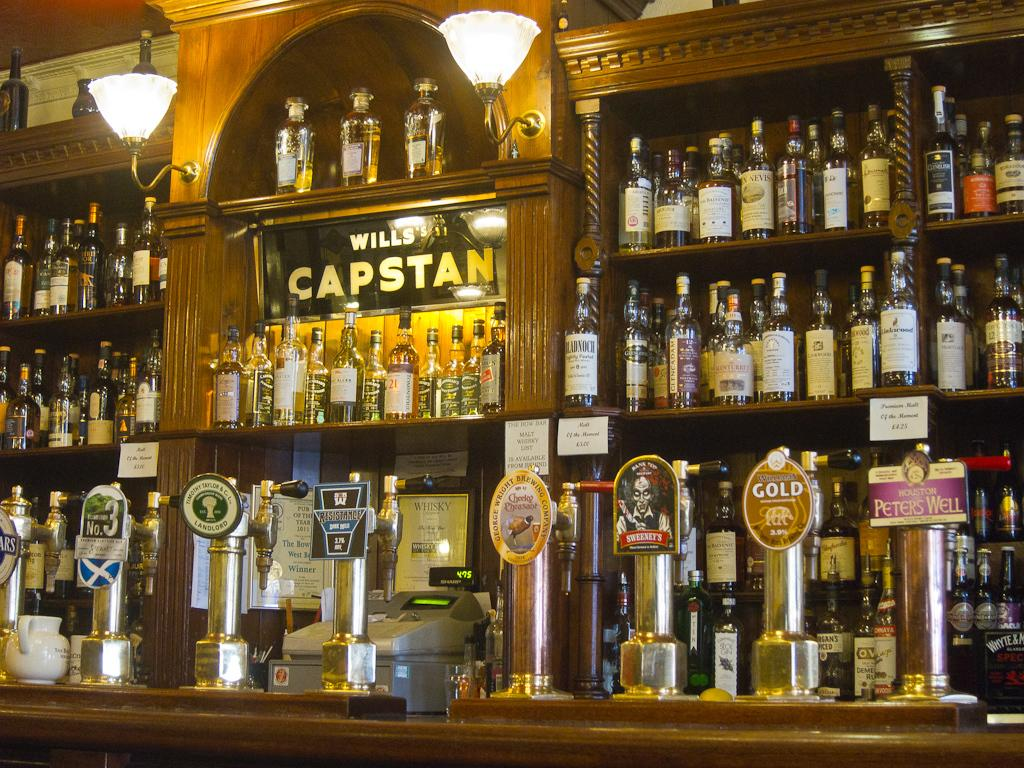<image>
Provide a brief description of the given image. Old fashioned wooden bar with multiple liquor bottles and beer taps with the name Wills's Capstan on the mirror. 